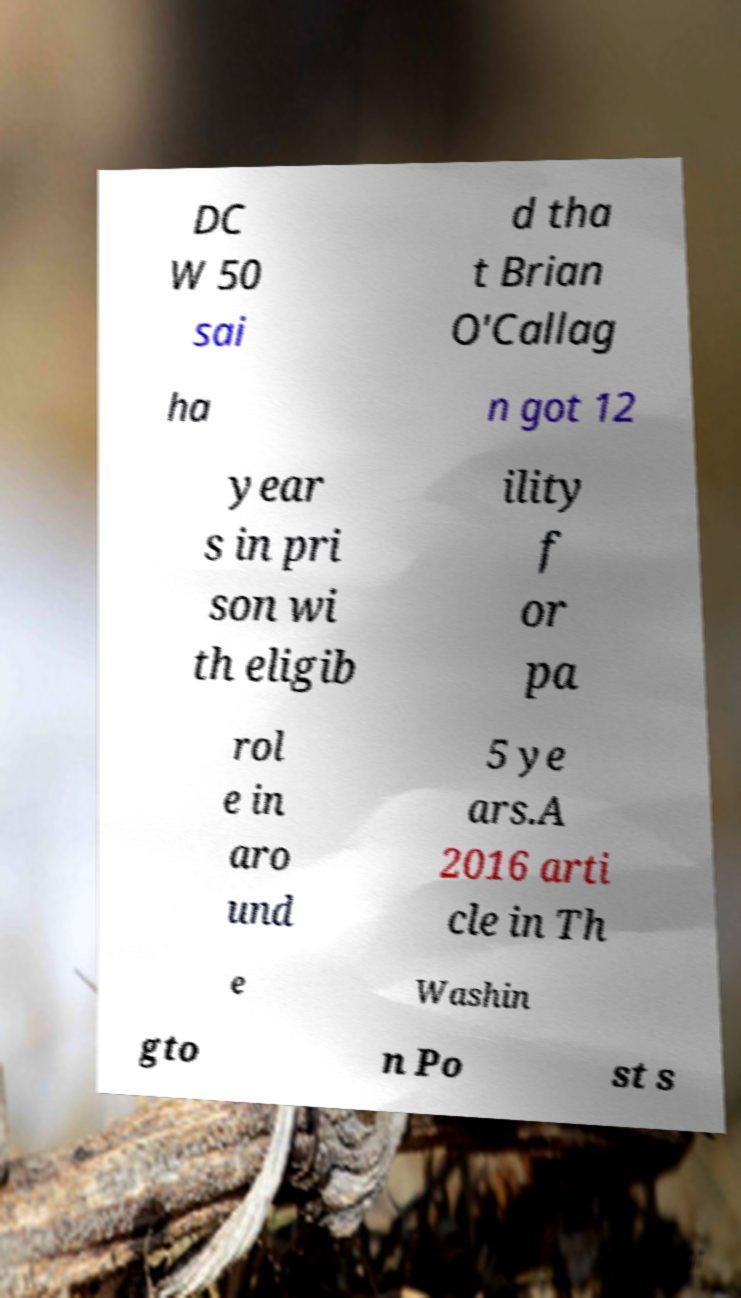What messages or text are displayed in this image? I need them in a readable, typed format. DC W 50 sai d tha t Brian O'Callag ha n got 12 year s in pri son wi th eligib ility f or pa rol e in aro und 5 ye ars.A 2016 arti cle in Th e Washin gto n Po st s 